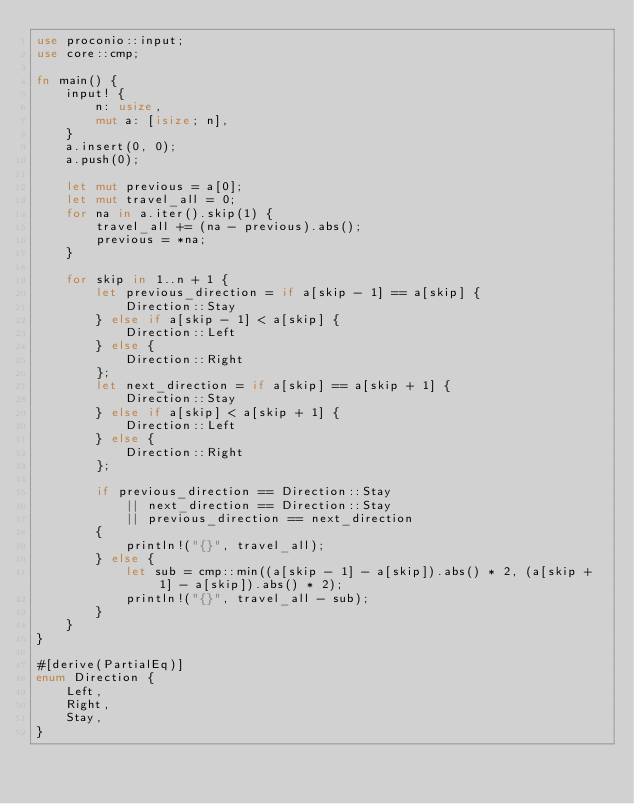Convert code to text. <code><loc_0><loc_0><loc_500><loc_500><_Rust_>use proconio::input;
use core::cmp;

fn main() {
    input! {
        n: usize,
        mut a: [isize; n],
    }
    a.insert(0, 0);
    a.push(0);

    let mut previous = a[0];
    let mut travel_all = 0;
    for na in a.iter().skip(1) {
        travel_all += (na - previous).abs();
        previous = *na;
    }

    for skip in 1..n + 1 {
        let previous_direction = if a[skip - 1] == a[skip] {
            Direction::Stay
        } else if a[skip - 1] < a[skip] {
            Direction::Left
        } else {
            Direction::Right
        };
        let next_direction = if a[skip] == a[skip + 1] {
            Direction::Stay
        } else if a[skip] < a[skip + 1] {
            Direction::Left
        } else {
            Direction::Right
        };

        if previous_direction == Direction::Stay
            || next_direction == Direction::Stay
            || previous_direction == next_direction
        {
            println!("{}", travel_all);
        } else {
            let sub = cmp::min((a[skip - 1] - a[skip]).abs() * 2, (a[skip + 1] - a[skip]).abs() * 2);
            println!("{}", travel_all - sub);
        }
    }
}

#[derive(PartialEq)]
enum Direction {
    Left,
    Right,
    Stay,
}
</code> 